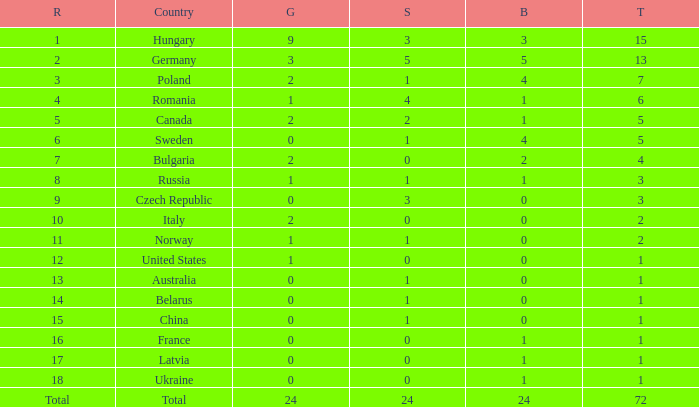What nation has 0 as the silver, 1 as the bronze, with 18 as the rank? Ukraine. 